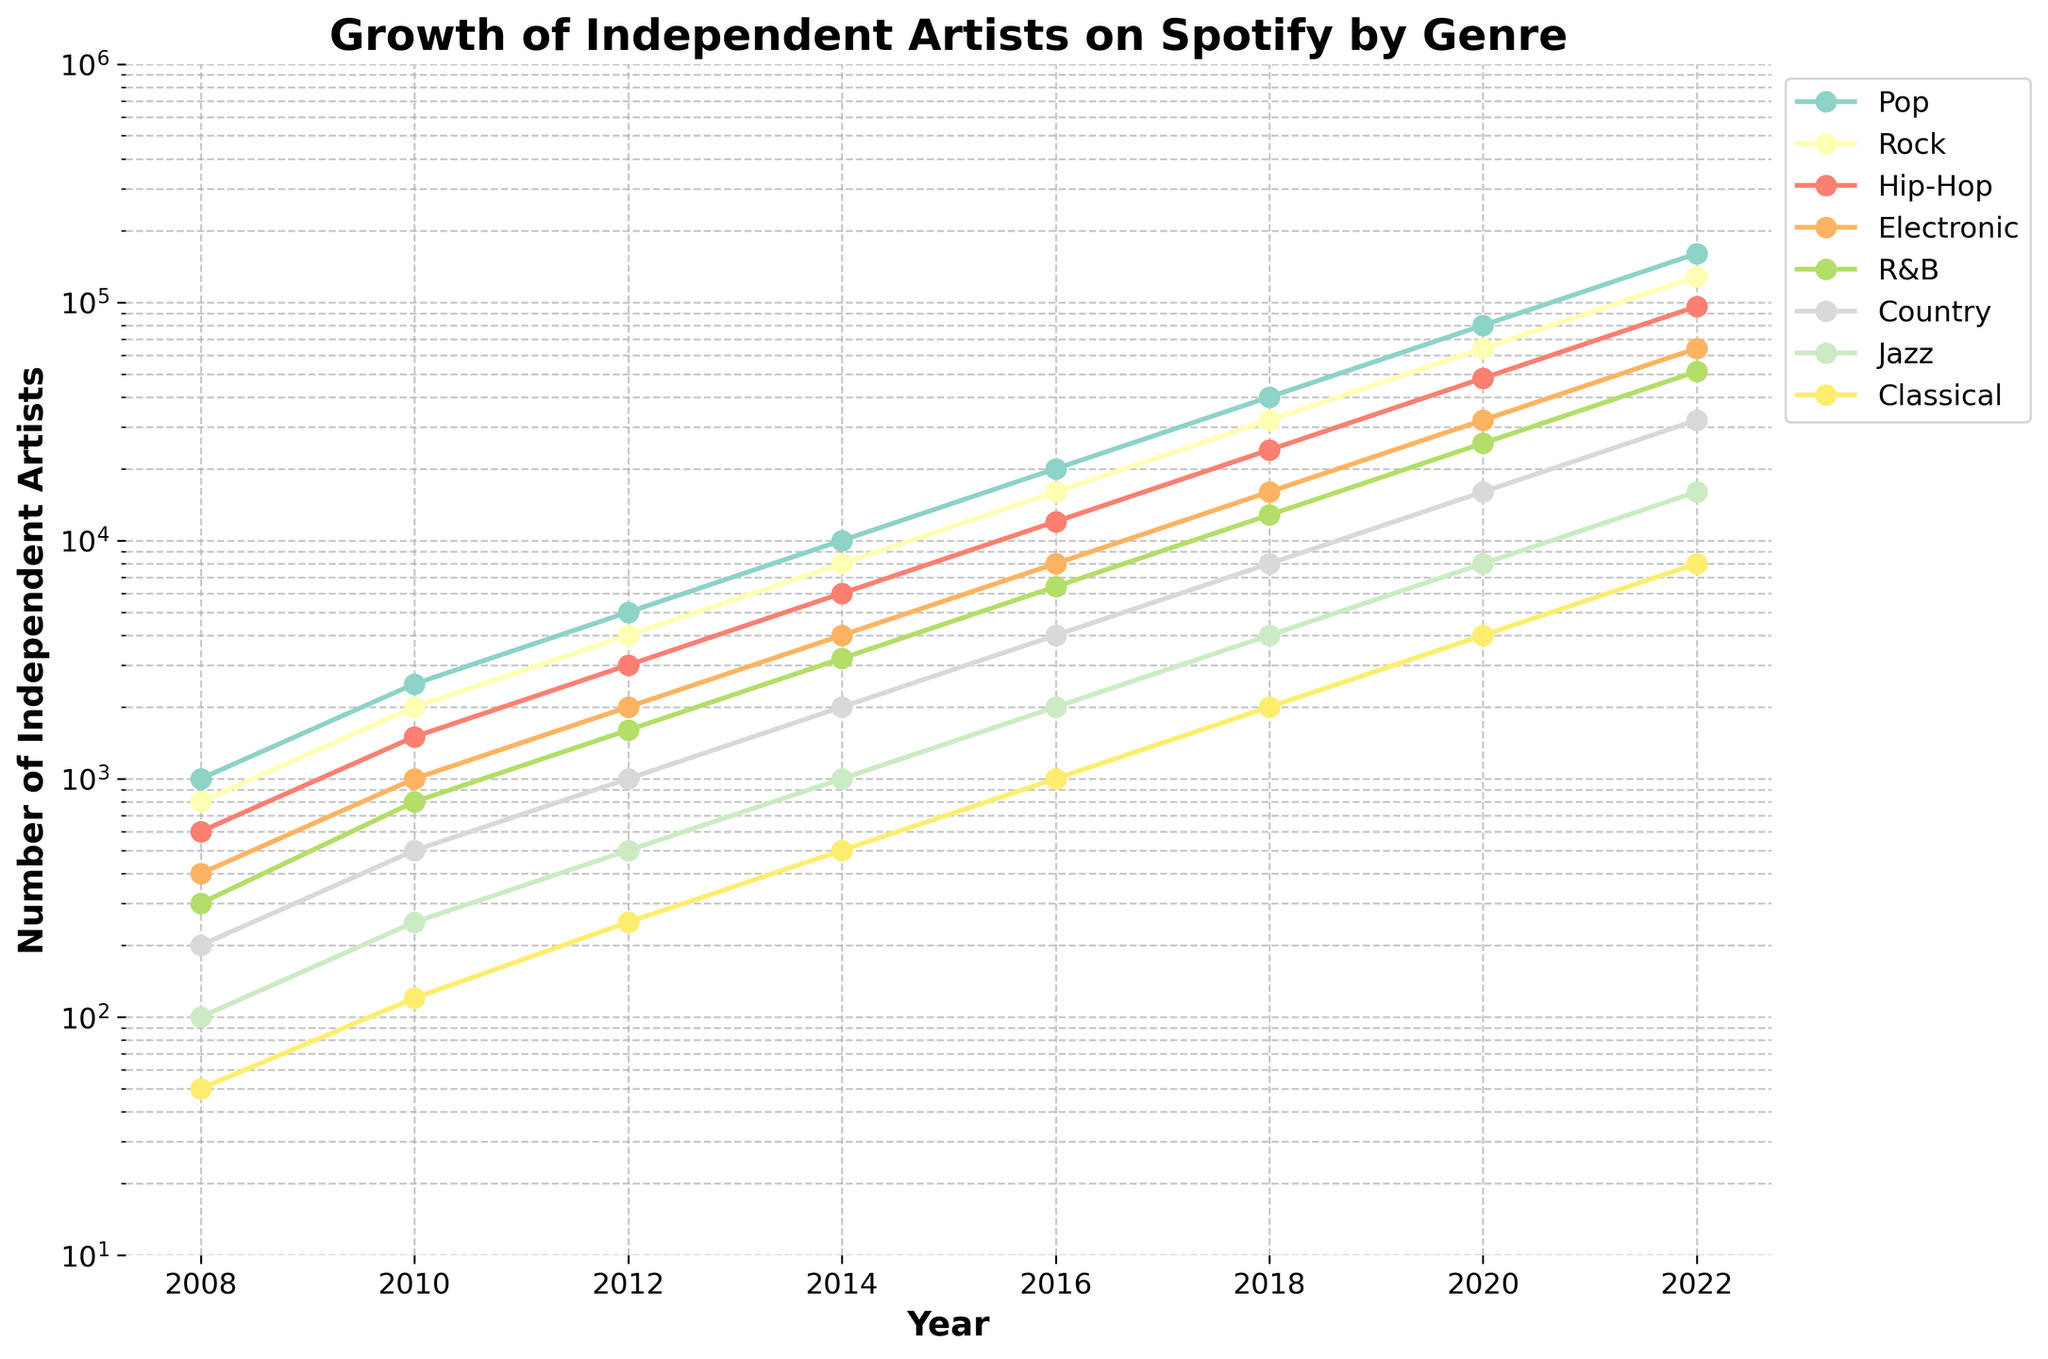What genre had the most significant growth in the number of independent artists from 2008 to 2022? Observe the figures for each genre in 2008 and 2022. Pop started at 1000 in 2008 and increased to 160,000 in 2022, showing the highest growth.
Answer: Pop Between Rock and Hip-Hop, which genre had more independent artists in 2016? Compare the values for Rock and Hip-Hop in 2016. Rock had 16,000, while Hip-Hop had 12,000.
Answer: Rock What is the average number of independent artists across all genres in 2022? Sum the number of artists in each genre for 2022 and divide by the number of genres: (160000 + 128000 + 96000 + 64000 + 51200 + 32000 + 16000 + 8000)/8 = 69000.
Answer: 69,000 Which genre experienced the least growth from 2008 to 2022? Compare the increase in numbers for each genre from 2008 to 2022. Classical went from 50 to 8000, showing the smallest growth.
Answer: Classical How many more independent artists were in the Pop genre compared to the Jazz genre in 2020? Subtract the number of Jazz artists from Pop artists in 2020: 80000 - 8000 = 72000.
Answer: 72,000 In what year did the number of independent R&B artists surpass 10,000? Check the R&B figures over the years. The number surpassed 10,000 in 2018.
Answer: 2018 